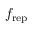Convert formula to latex. <formula><loc_0><loc_0><loc_500><loc_500>f _ { r e p }</formula> 